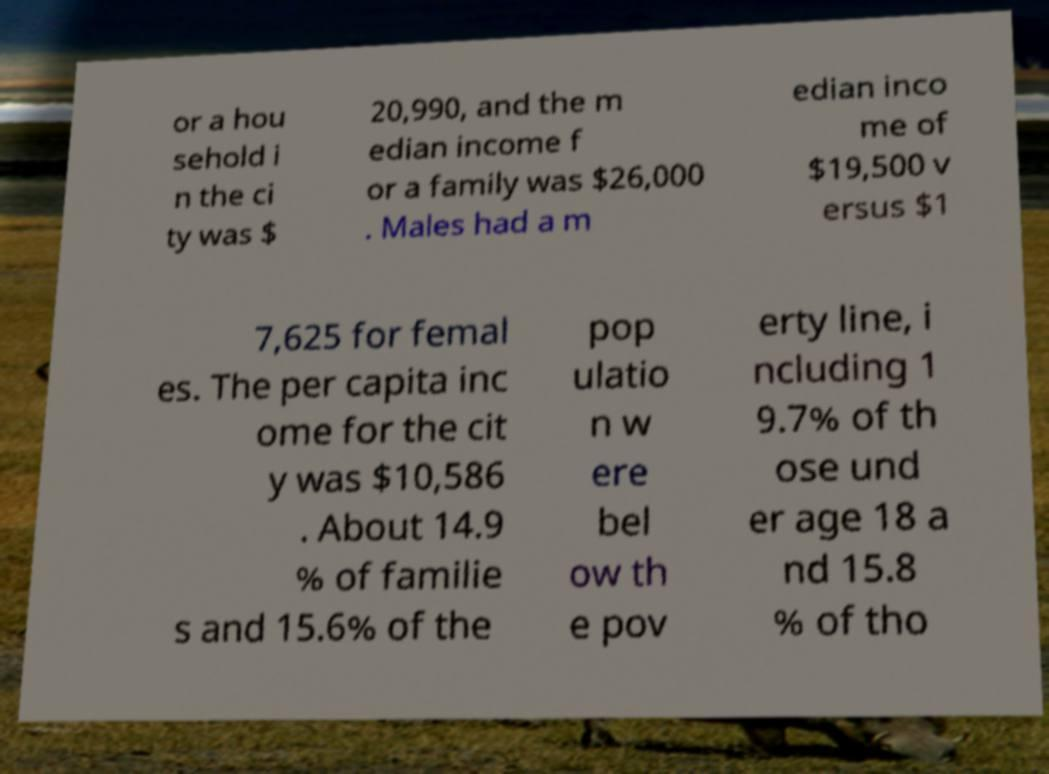Could you extract and type out the text from this image? or a hou sehold i n the ci ty was $ 20,990, and the m edian income f or a family was $26,000 . Males had a m edian inco me of $19,500 v ersus $1 7,625 for femal es. The per capita inc ome for the cit y was $10,586 . About 14.9 % of familie s and 15.6% of the pop ulatio n w ere bel ow th e pov erty line, i ncluding 1 9.7% of th ose und er age 18 a nd 15.8 % of tho 